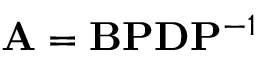Convert formula to latex. <formula><loc_0><loc_0><loc_500><loc_500>A = B P D P ^ { - 1 }</formula> 